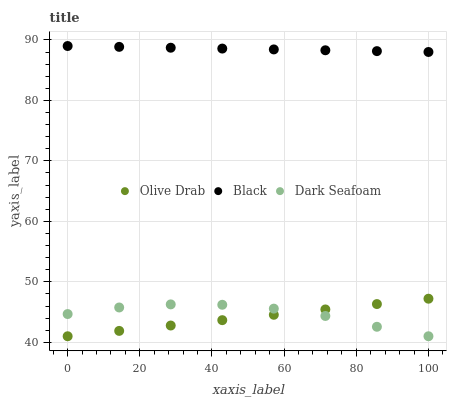Does Olive Drab have the minimum area under the curve?
Answer yes or no. Yes. Does Black have the maximum area under the curve?
Answer yes or no. Yes. Does Black have the minimum area under the curve?
Answer yes or no. No. Does Olive Drab have the maximum area under the curve?
Answer yes or no. No. Is Black the smoothest?
Answer yes or no. Yes. Is Dark Seafoam the roughest?
Answer yes or no. Yes. Is Olive Drab the smoothest?
Answer yes or no. No. Is Olive Drab the roughest?
Answer yes or no. No. Does Dark Seafoam have the lowest value?
Answer yes or no. Yes. Does Black have the lowest value?
Answer yes or no. No. Does Black have the highest value?
Answer yes or no. Yes. Does Olive Drab have the highest value?
Answer yes or no. No. Is Olive Drab less than Black?
Answer yes or no. Yes. Is Black greater than Olive Drab?
Answer yes or no. Yes. Does Olive Drab intersect Dark Seafoam?
Answer yes or no. Yes. Is Olive Drab less than Dark Seafoam?
Answer yes or no. No. Is Olive Drab greater than Dark Seafoam?
Answer yes or no. No. Does Olive Drab intersect Black?
Answer yes or no. No. 